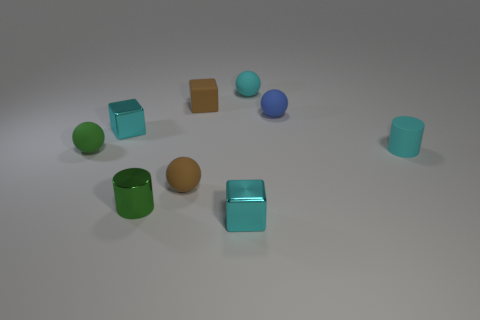Add 1 cyan matte things. How many objects exist? 10 Subtract all blue spheres. How many spheres are left? 3 Subtract 1 cylinders. How many cylinders are left? 1 Subtract all cyan blocks. How many blocks are left? 1 Subtract all balls. How many objects are left? 5 Subtract all brown cylinders. How many blue balls are left? 1 Subtract all big yellow matte balls. Subtract all brown balls. How many objects are left? 8 Add 5 green rubber balls. How many green rubber balls are left? 6 Add 5 large gray shiny cylinders. How many large gray shiny cylinders exist? 5 Subtract 0 purple balls. How many objects are left? 9 